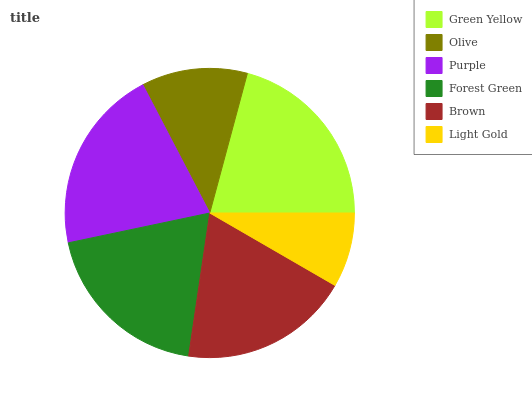Is Light Gold the minimum?
Answer yes or no. Yes. Is Green Yellow the maximum?
Answer yes or no. Yes. Is Olive the minimum?
Answer yes or no. No. Is Olive the maximum?
Answer yes or no. No. Is Green Yellow greater than Olive?
Answer yes or no. Yes. Is Olive less than Green Yellow?
Answer yes or no. Yes. Is Olive greater than Green Yellow?
Answer yes or no. No. Is Green Yellow less than Olive?
Answer yes or no. No. Is Forest Green the high median?
Answer yes or no. Yes. Is Brown the low median?
Answer yes or no. Yes. Is Green Yellow the high median?
Answer yes or no. No. Is Olive the low median?
Answer yes or no. No. 